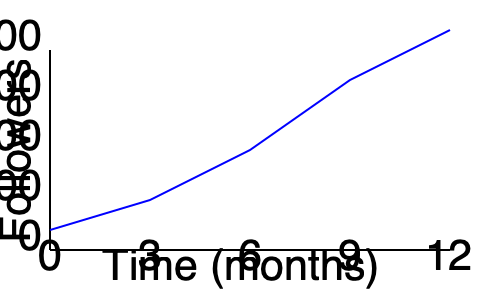As a debut author, you've been tracking your social media growth over the past year. The graph shows the number of followers you've gained each month. What is the approximate percentage increase in followers from the 3-month mark to the 9-month mark? To calculate the percentage increase in followers from the 3-month mark to the 9-month mark, we'll follow these steps:

1. Identify the number of followers at 3 months:
   At the 3-month mark (x-axis value 3), the y-axis value is approximately 500 followers.

2. Identify the number of followers at 9 months:
   At the 9-month mark (x-axis value 9), the y-axis value is approximately 1500 followers.

3. Calculate the increase in followers:
   Increase = Followers at 9 months - Followers at 3 months
   Increase = 1500 - 500 = 1000 followers

4. Calculate the percentage increase:
   Percentage increase = (Increase / Original number) × 100
   Percentage increase = (1000 / 500) × 100 = 2 × 100 = 200%

Therefore, the approximate percentage increase in followers from the 3-month mark to the 9-month mark is 200%.
Answer: 200% 